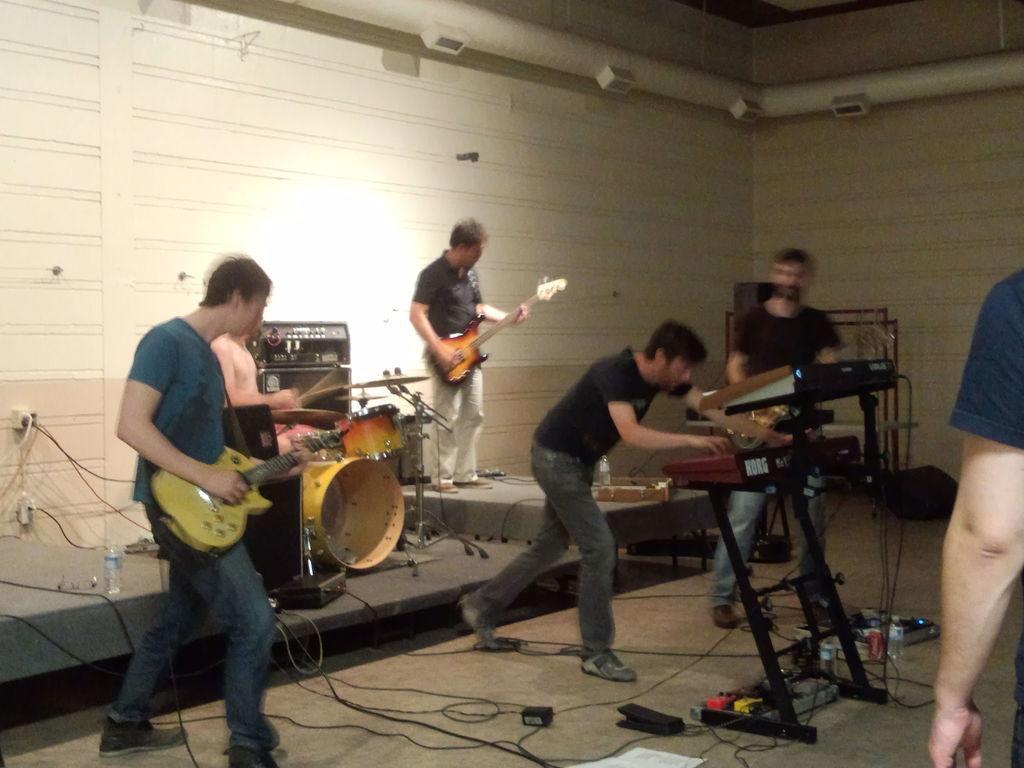Please provide a concise description of this image. In this image there are group of persons who are playing musical instruments. 